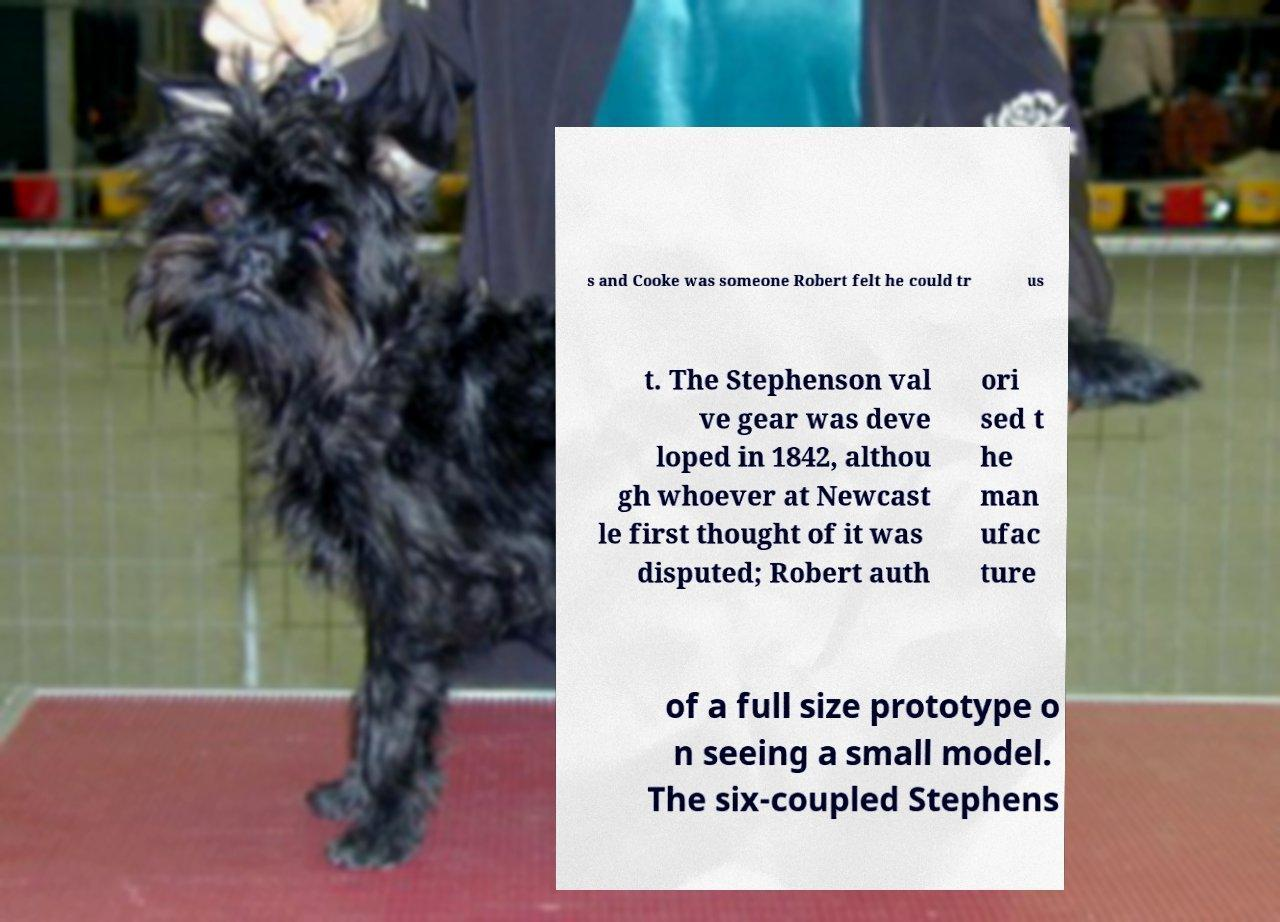There's text embedded in this image that I need extracted. Can you transcribe it verbatim? s and Cooke was someone Robert felt he could tr us t. The Stephenson val ve gear was deve loped in 1842, althou gh whoever at Newcast le first thought of it was disputed; Robert auth ori sed t he man ufac ture of a full size prototype o n seeing a small model. The six-coupled Stephens 